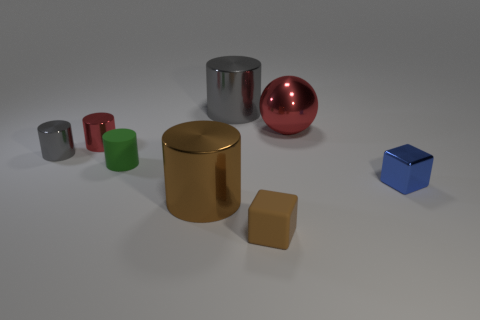There is a object that is the same color as the large ball; what material is it?
Make the answer very short. Metal. There is a matte object in front of the blue cube; are there any small things that are in front of it?
Your response must be concise. No. How many gray metal cylinders are behind the tiny gray cylinder?
Offer a terse response. 1. How many other objects are the same color as the small matte cube?
Make the answer very short. 1. Are there fewer blocks that are to the left of the tiny brown rubber cube than tiny green objects on the right side of the tiny green matte thing?
Provide a succinct answer. No. How many things are either big cylinders that are in front of the big gray metal thing or small shiny cubes?
Provide a succinct answer. 2. There is a green object; does it have the same size as the red thing in front of the big shiny sphere?
Ensure brevity in your answer.  Yes. There is another gray metallic thing that is the same shape as the tiny gray thing; what is its size?
Provide a short and direct response. Large. There is a tiny metallic cylinder that is on the right side of the gray metallic cylinder to the left of the tiny matte cylinder; how many tiny green cylinders are in front of it?
Your answer should be very brief. 1. How many cubes are either big brown shiny things or red shiny things?
Give a very brief answer. 0. 